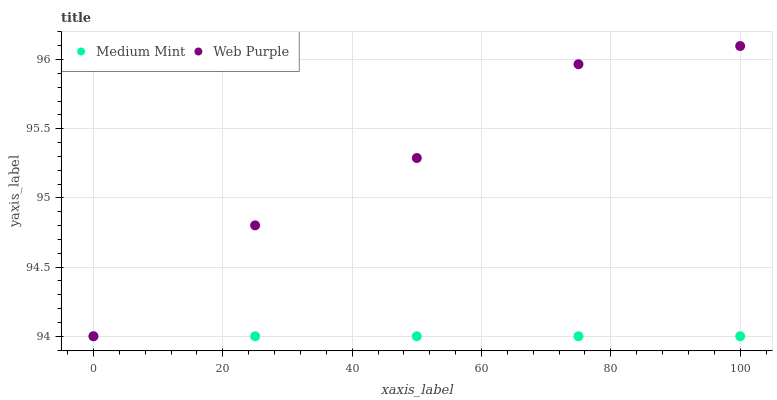Does Medium Mint have the minimum area under the curve?
Answer yes or no. Yes. Does Web Purple have the maximum area under the curve?
Answer yes or no. Yes. Does Web Purple have the minimum area under the curve?
Answer yes or no. No. Is Medium Mint the smoothest?
Answer yes or no. Yes. Is Web Purple the roughest?
Answer yes or no. Yes. Is Web Purple the smoothest?
Answer yes or no. No. Does Medium Mint have the lowest value?
Answer yes or no. Yes. Does Web Purple have the highest value?
Answer yes or no. Yes. Does Web Purple intersect Medium Mint?
Answer yes or no. Yes. Is Web Purple less than Medium Mint?
Answer yes or no. No. Is Web Purple greater than Medium Mint?
Answer yes or no. No. 